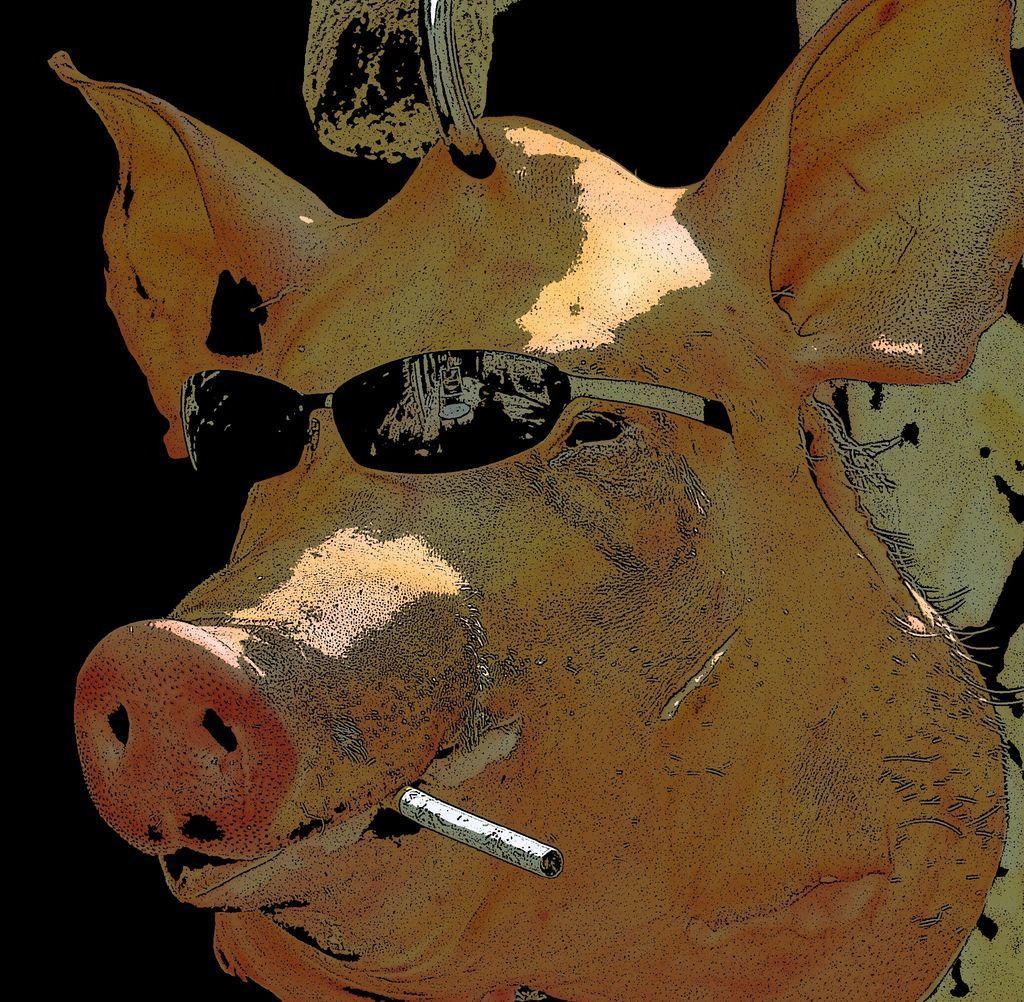Describe this image in one or two sentences. In this picture we can see a depiction of a pig wearing goggle, there is a cigar on pig's mouth, we can see a dark background. 